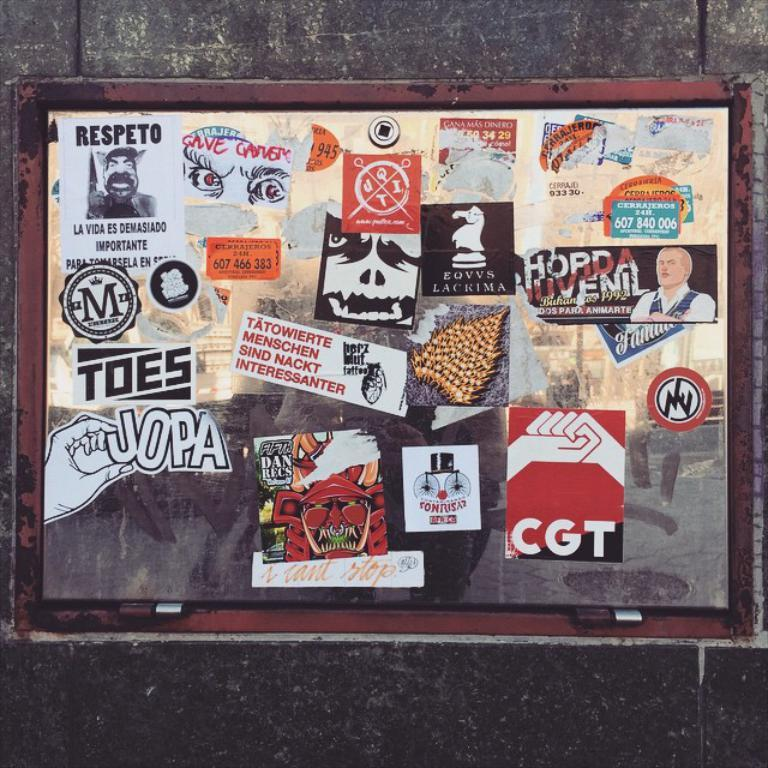What is the main object in the center of the image? There is a board in the center of the image. What is displayed on the board? There are posters on the board. What can be read on the posters? There is text on the posters. What can be seen in the background of the image? There is a wall in the background of the image. What type of badge is pinned to the wall in the image? There is no badge present in the image; it only features a board with posters and a wall in the background. 